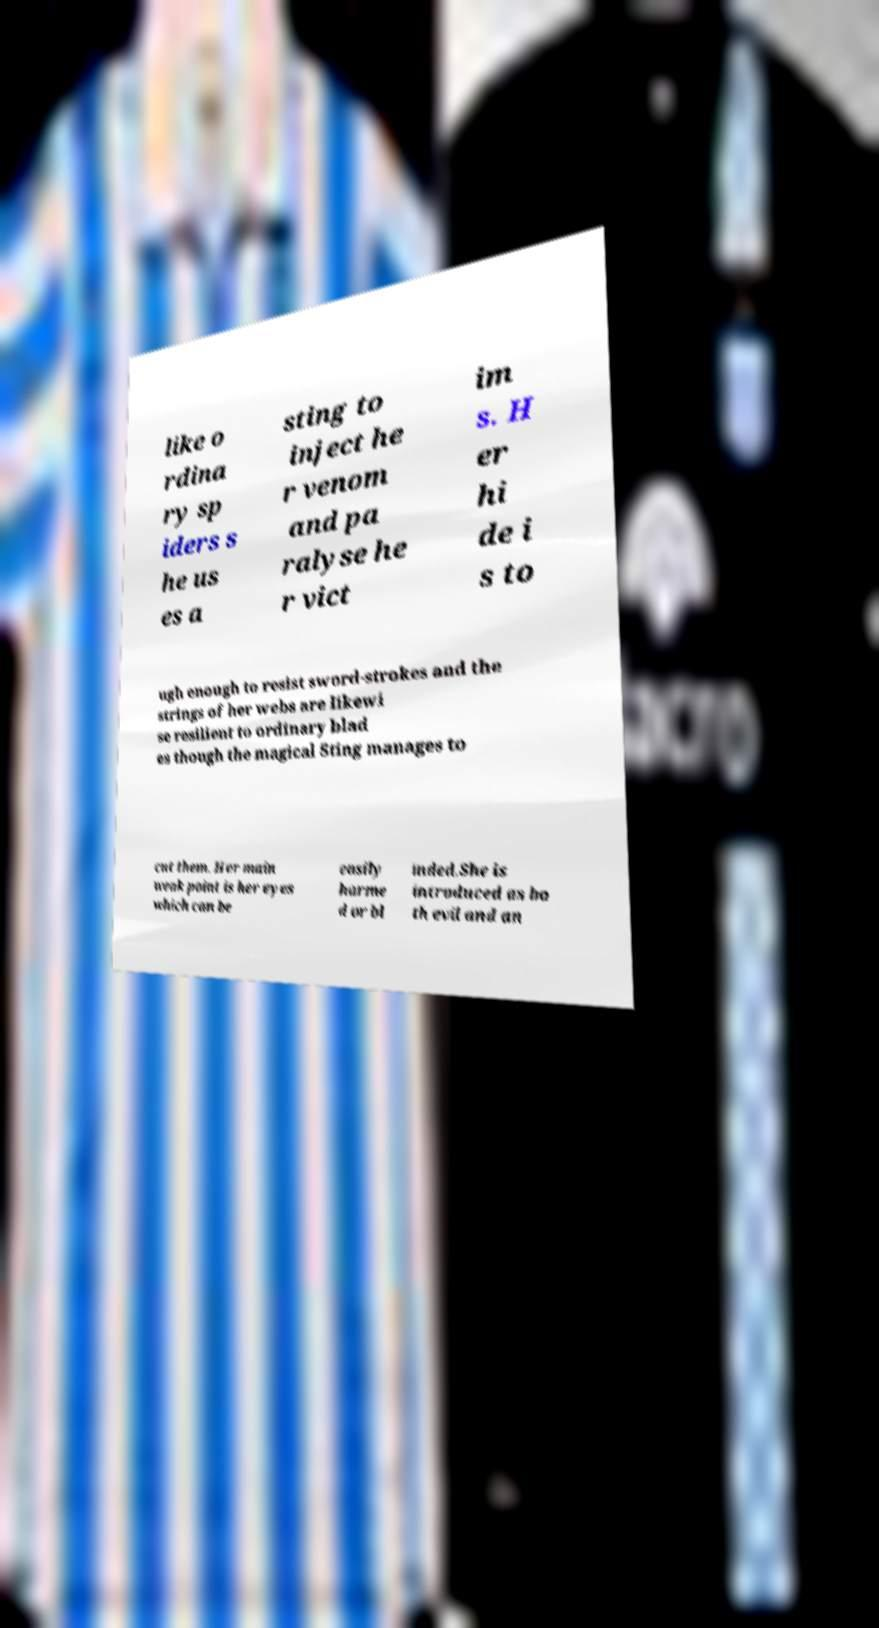Can you read and provide the text displayed in the image?This photo seems to have some interesting text. Can you extract and type it out for me? like o rdina ry sp iders s he us es a sting to inject he r venom and pa ralyse he r vict im s. H er hi de i s to ugh enough to resist sword-strokes and the strings of her webs are likewi se resilient to ordinary blad es though the magical Sting manages to cut them. Her main weak point is her eyes which can be easily harme d or bl inded.She is introduced as bo th evil and an 